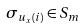<formula> <loc_0><loc_0><loc_500><loc_500>\sigma _ { u _ { x } ( i ) } \in S _ { m }</formula> 